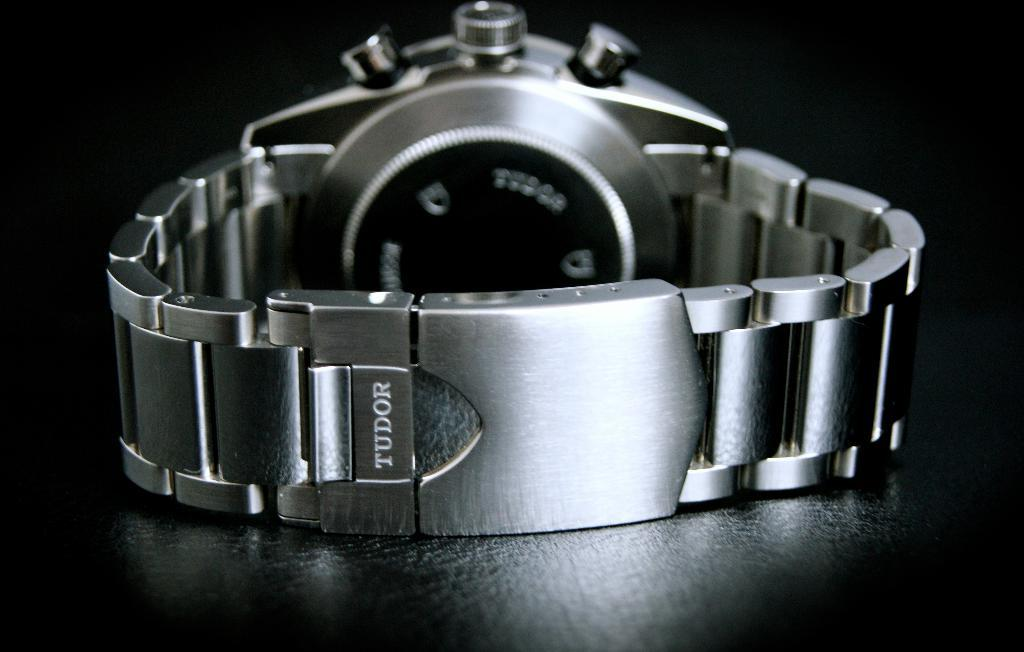<image>
Give a short and clear explanation of the subsequent image. The back of a silver Tudor watch with the band snapped shut. 